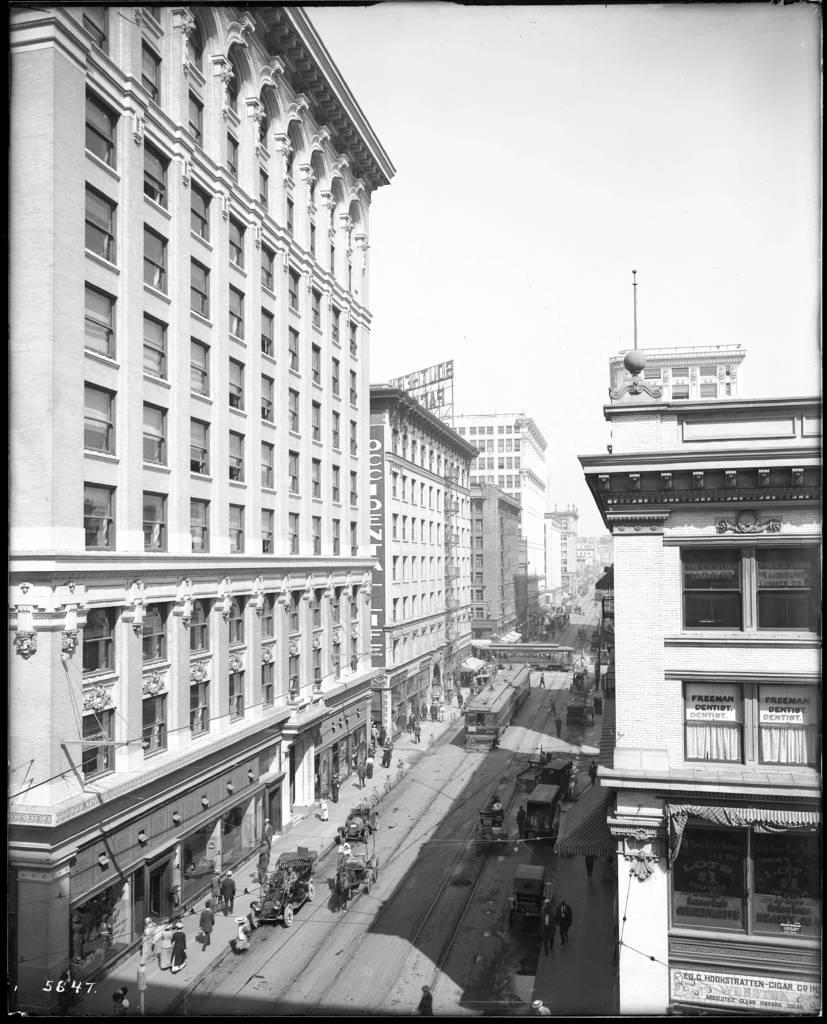What type of structures can be seen in the image? There are buildings in the image. What else is present in the image besides the buildings? There is a road in the image, and vehicles are moving on the road. What is the color scheme of the image? The image is black and white. What can be seen in the background of the image? There is a sky visible in the background of the image. What type of card is being used to generate steam in the image? There is no card or steam present in the image; it features buildings, a road, vehicles, and a black and white color scheme. What type of ornament is hanging from the buildings in the image? There is no ornament hanging from the buildings in the image; it only features buildings, a road, vehicles, and a black and white color scheme. 